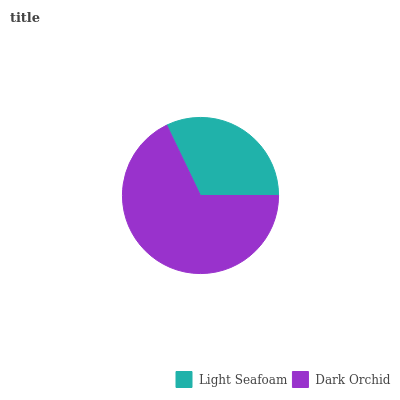Is Light Seafoam the minimum?
Answer yes or no. Yes. Is Dark Orchid the maximum?
Answer yes or no. Yes. Is Dark Orchid the minimum?
Answer yes or no. No. Is Dark Orchid greater than Light Seafoam?
Answer yes or no. Yes. Is Light Seafoam less than Dark Orchid?
Answer yes or no. Yes. Is Light Seafoam greater than Dark Orchid?
Answer yes or no. No. Is Dark Orchid less than Light Seafoam?
Answer yes or no. No. Is Dark Orchid the high median?
Answer yes or no. Yes. Is Light Seafoam the low median?
Answer yes or no. Yes. Is Light Seafoam the high median?
Answer yes or no. No. Is Dark Orchid the low median?
Answer yes or no. No. 